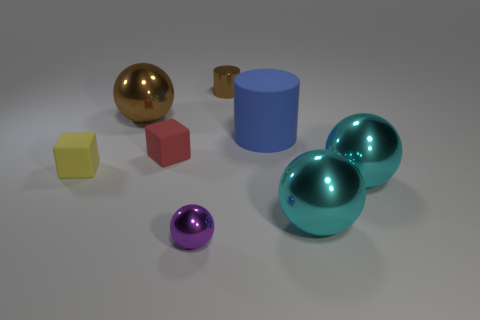There is a small matte object on the right side of the big brown sphere; are there any brown objects in front of it?
Your response must be concise. No. Do the rubber cylinder and the small ball have the same color?
Your answer should be very brief. No. What number of other objects are the same shape as the tiny red thing?
Give a very brief answer. 1. Are there more tiny metallic cylinders in front of the small red thing than small brown cylinders that are on the left side of the yellow matte block?
Your answer should be very brief. No. Does the brown shiny object left of the brown cylinder have the same size as the matte thing to the right of the small brown metallic object?
Provide a short and direct response. Yes. What shape is the purple shiny object?
Your response must be concise. Sphere. What size is the ball that is the same color as the tiny metal cylinder?
Ensure brevity in your answer.  Large. What color is the tiny ball that is the same material as the small brown cylinder?
Offer a terse response. Purple. Are the brown ball and the tiny thing that is on the right side of the purple object made of the same material?
Your response must be concise. Yes. The small shiny cylinder is what color?
Provide a short and direct response. Brown. 